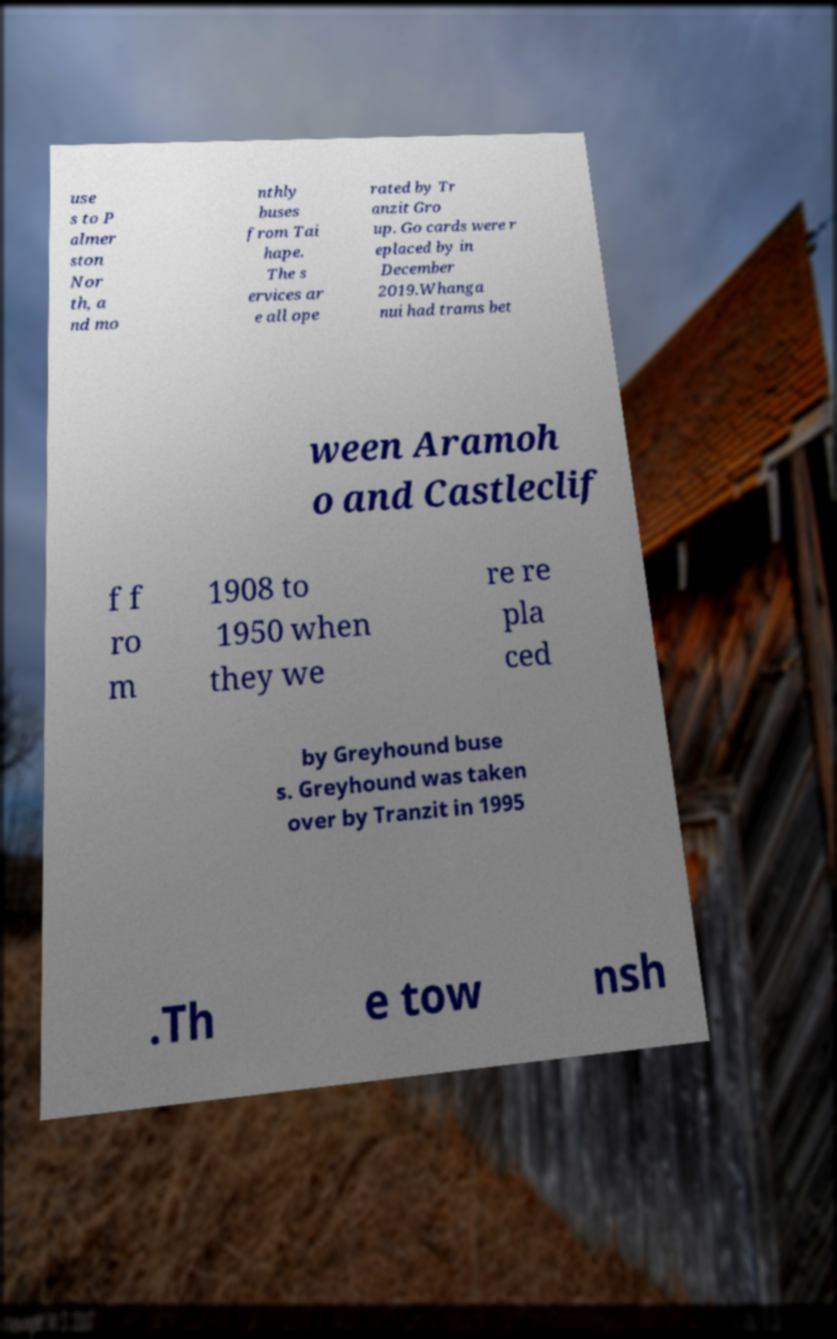I need the written content from this picture converted into text. Can you do that? use s to P almer ston Nor th, a nd mo nthly buses from Tai hape. The s ervices ar e all ope rated by Tr anzit Gro up. Go cards were r eplaced by in December 2019.Whanga nui had trams bet ween Aramoh o and Castleclif f f ro m 1908 to 1950 when they we re re pla ced by Greyhound buse s. Greyhound was taken over by Tranzit in 1995 .Th e tow nsh 